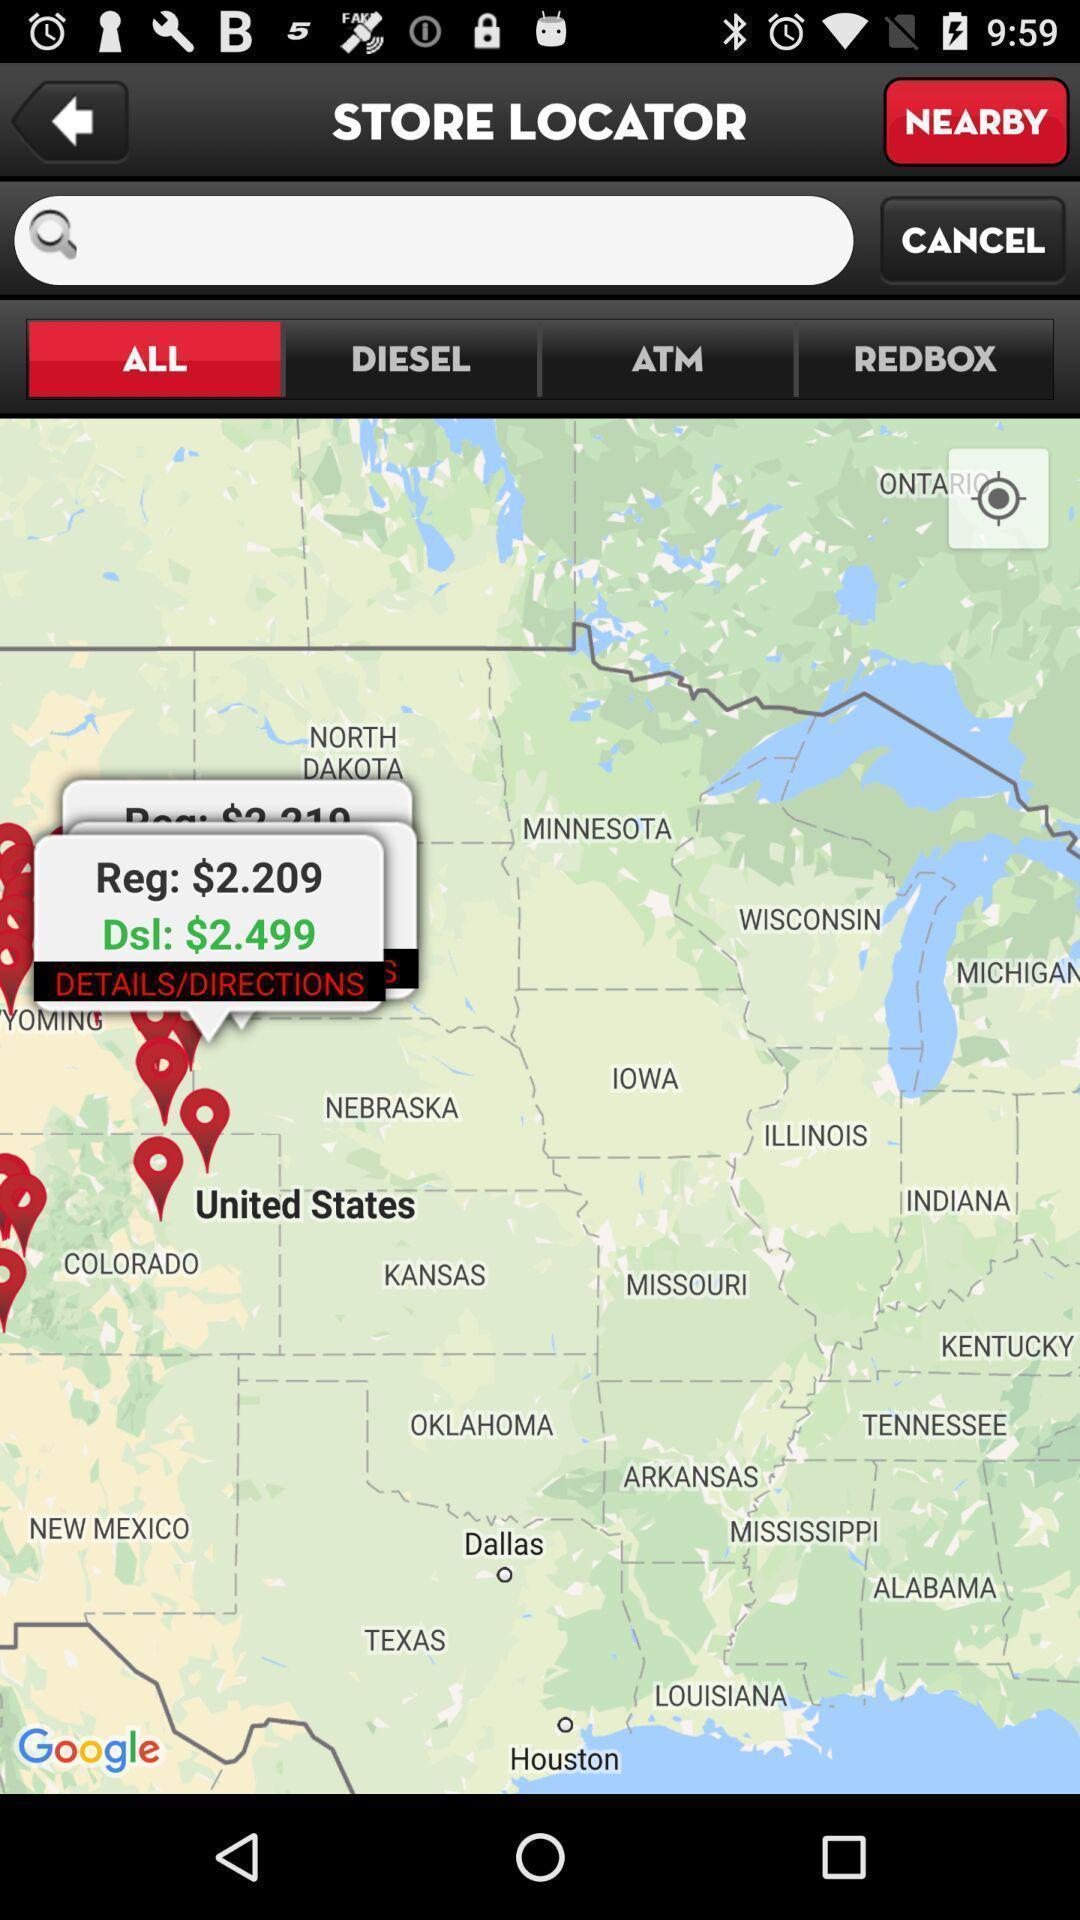Describe the key features of this screenshot. Screen showing multiple stores in a mapping location. 